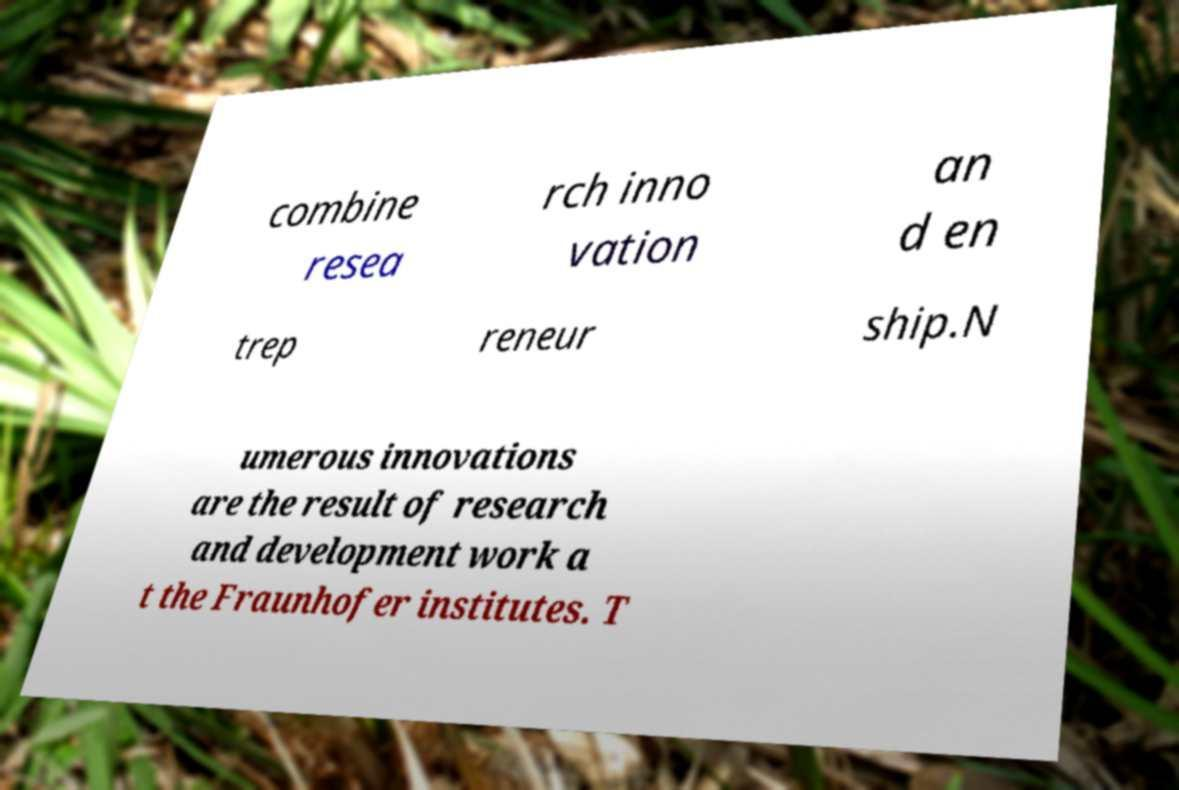For documentation purposes, I need the text within this image transcribed. Could you provide that? combine resea rch inno vation an d en trep reneur ship.N umerous innovations are the result of research and development work a t the Fraunhofer institutes. T 